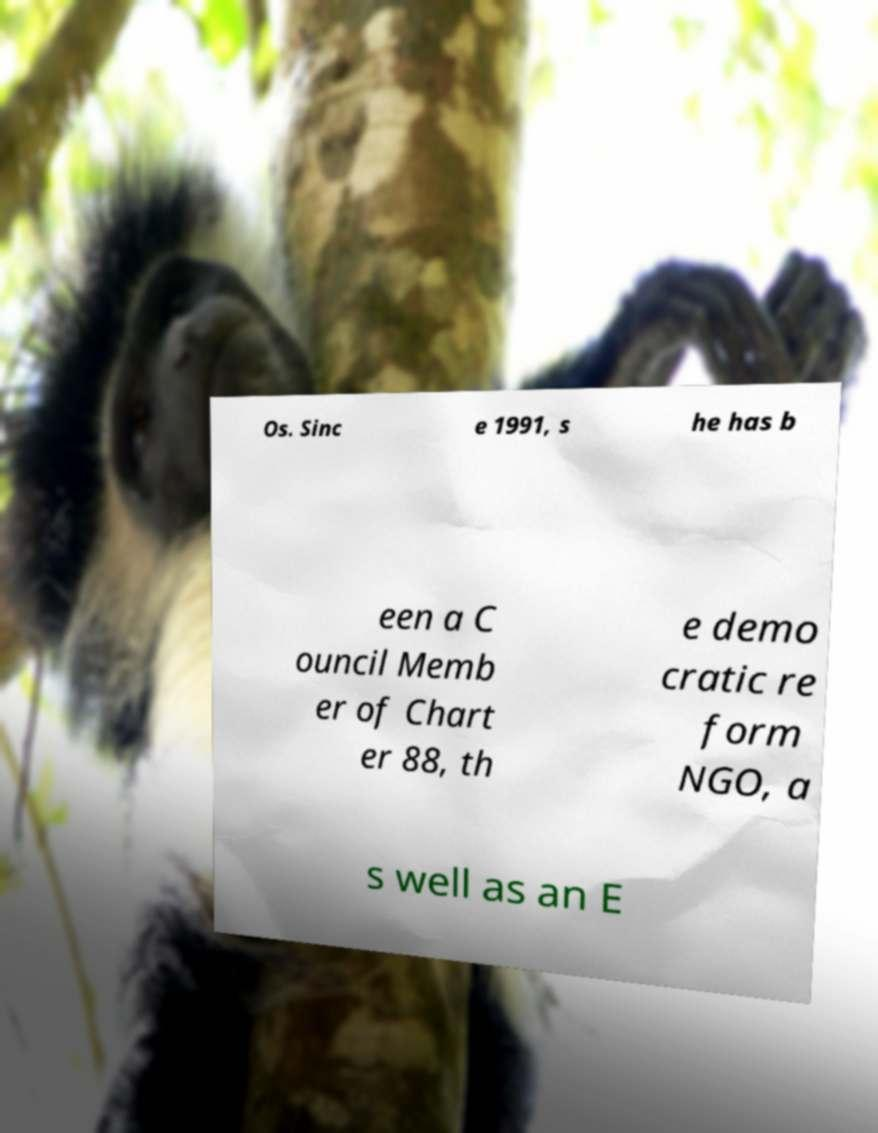For documentation purposes, I need the text within this image transcribed. Could you provide that? Os. Sinc e 1991, s he has b een a C ouncil Memb er of Chart er 88, th e demo cratic re form NGO, a s well as an E 